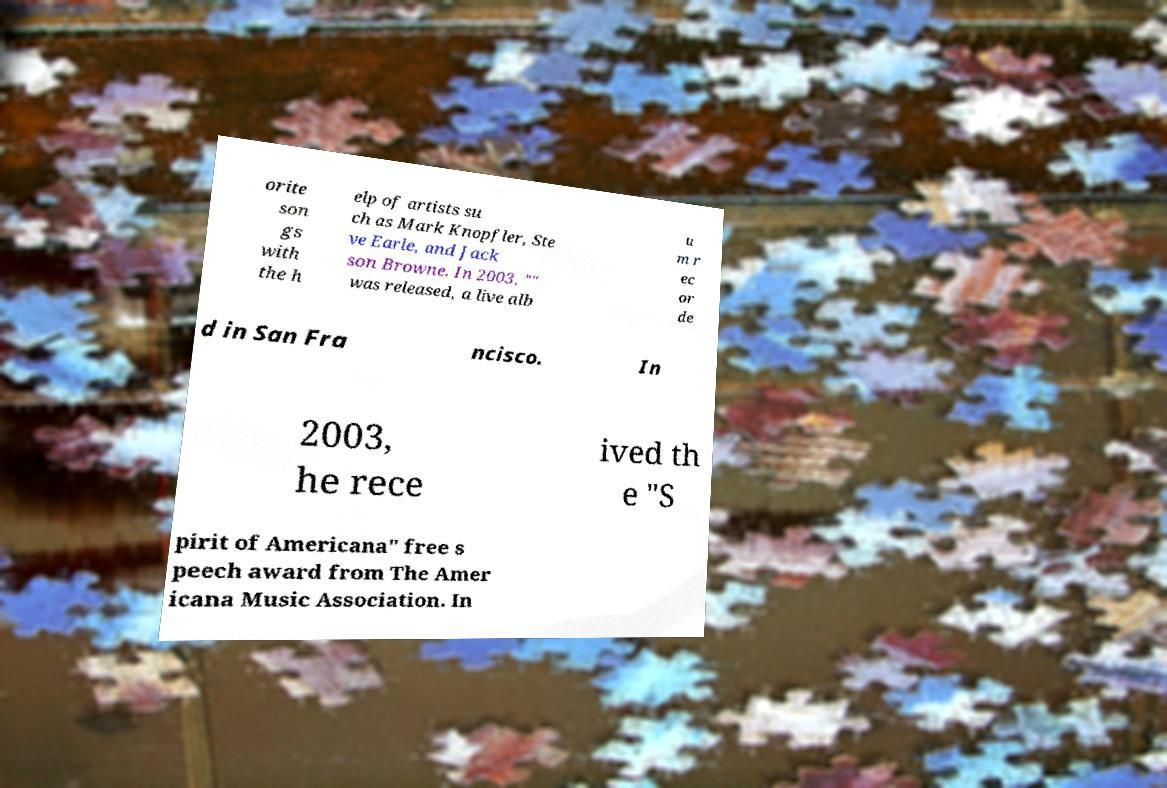Could you assist in decoding the text presented in this image and type it out clearly? orite son gs with the h elp of artists su ch as Mark Knopfler, Ste ve Earle, and Jack son Browne. In 2003, "" was released, a live alb u m r ec or de d in San Fra ncisco. In 2003, he rece ived th e "S pirit of Americana" free s peech award from The Amer icana Music Association. In 